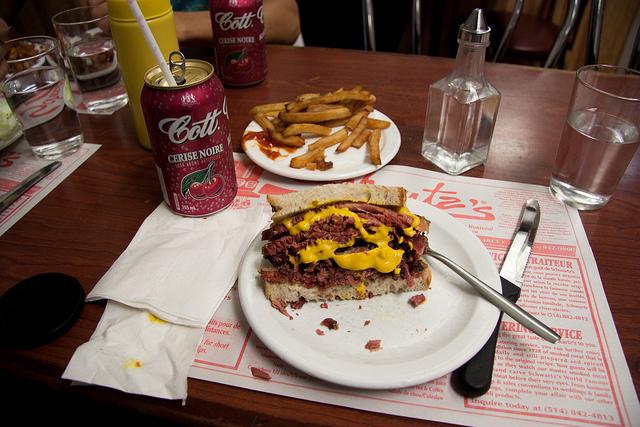Does it look like someone started to eat the food on the table?
Be succinct. Yes. What brand of soda?
Answer briefly. Cott. Is this a diner?
Short answer required. Yes. Why is half of the cake eaten?
Quick response, please. Not cake. What color is the front plate?
Write a very short answer. White. Are the fork prongs touching the table?
Be succinct. No. 